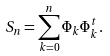<formula> <loc_0><loc_0><loc_500><loc_500>S _ { n } = \sum _ { k = 0 } ^ { n } \Phi _ { k } \Phi _ { k } ^ { t } .</formula> 